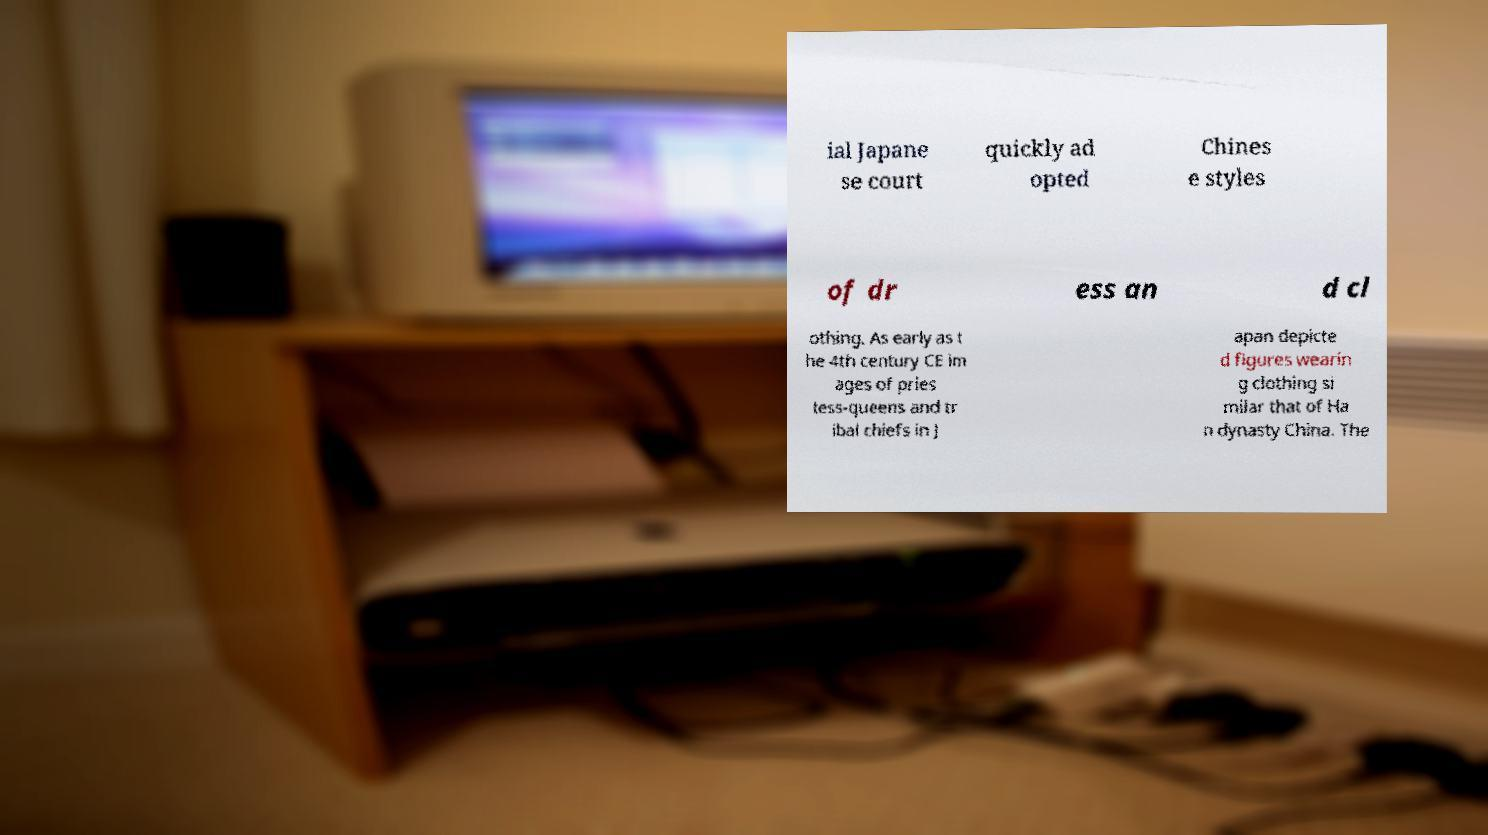There's text embedded in this image that I need extracted. Can you transcribe it verbatim? ial Japane se court quickly ad opted Chines e styles of dr ess an d cl othing. As early as t he 4th century CE im ages of pries tess-queens and tr ibal chiefs in J apan depicte d figures wearin g clothing si milar that of Ha n dynasty China. The 